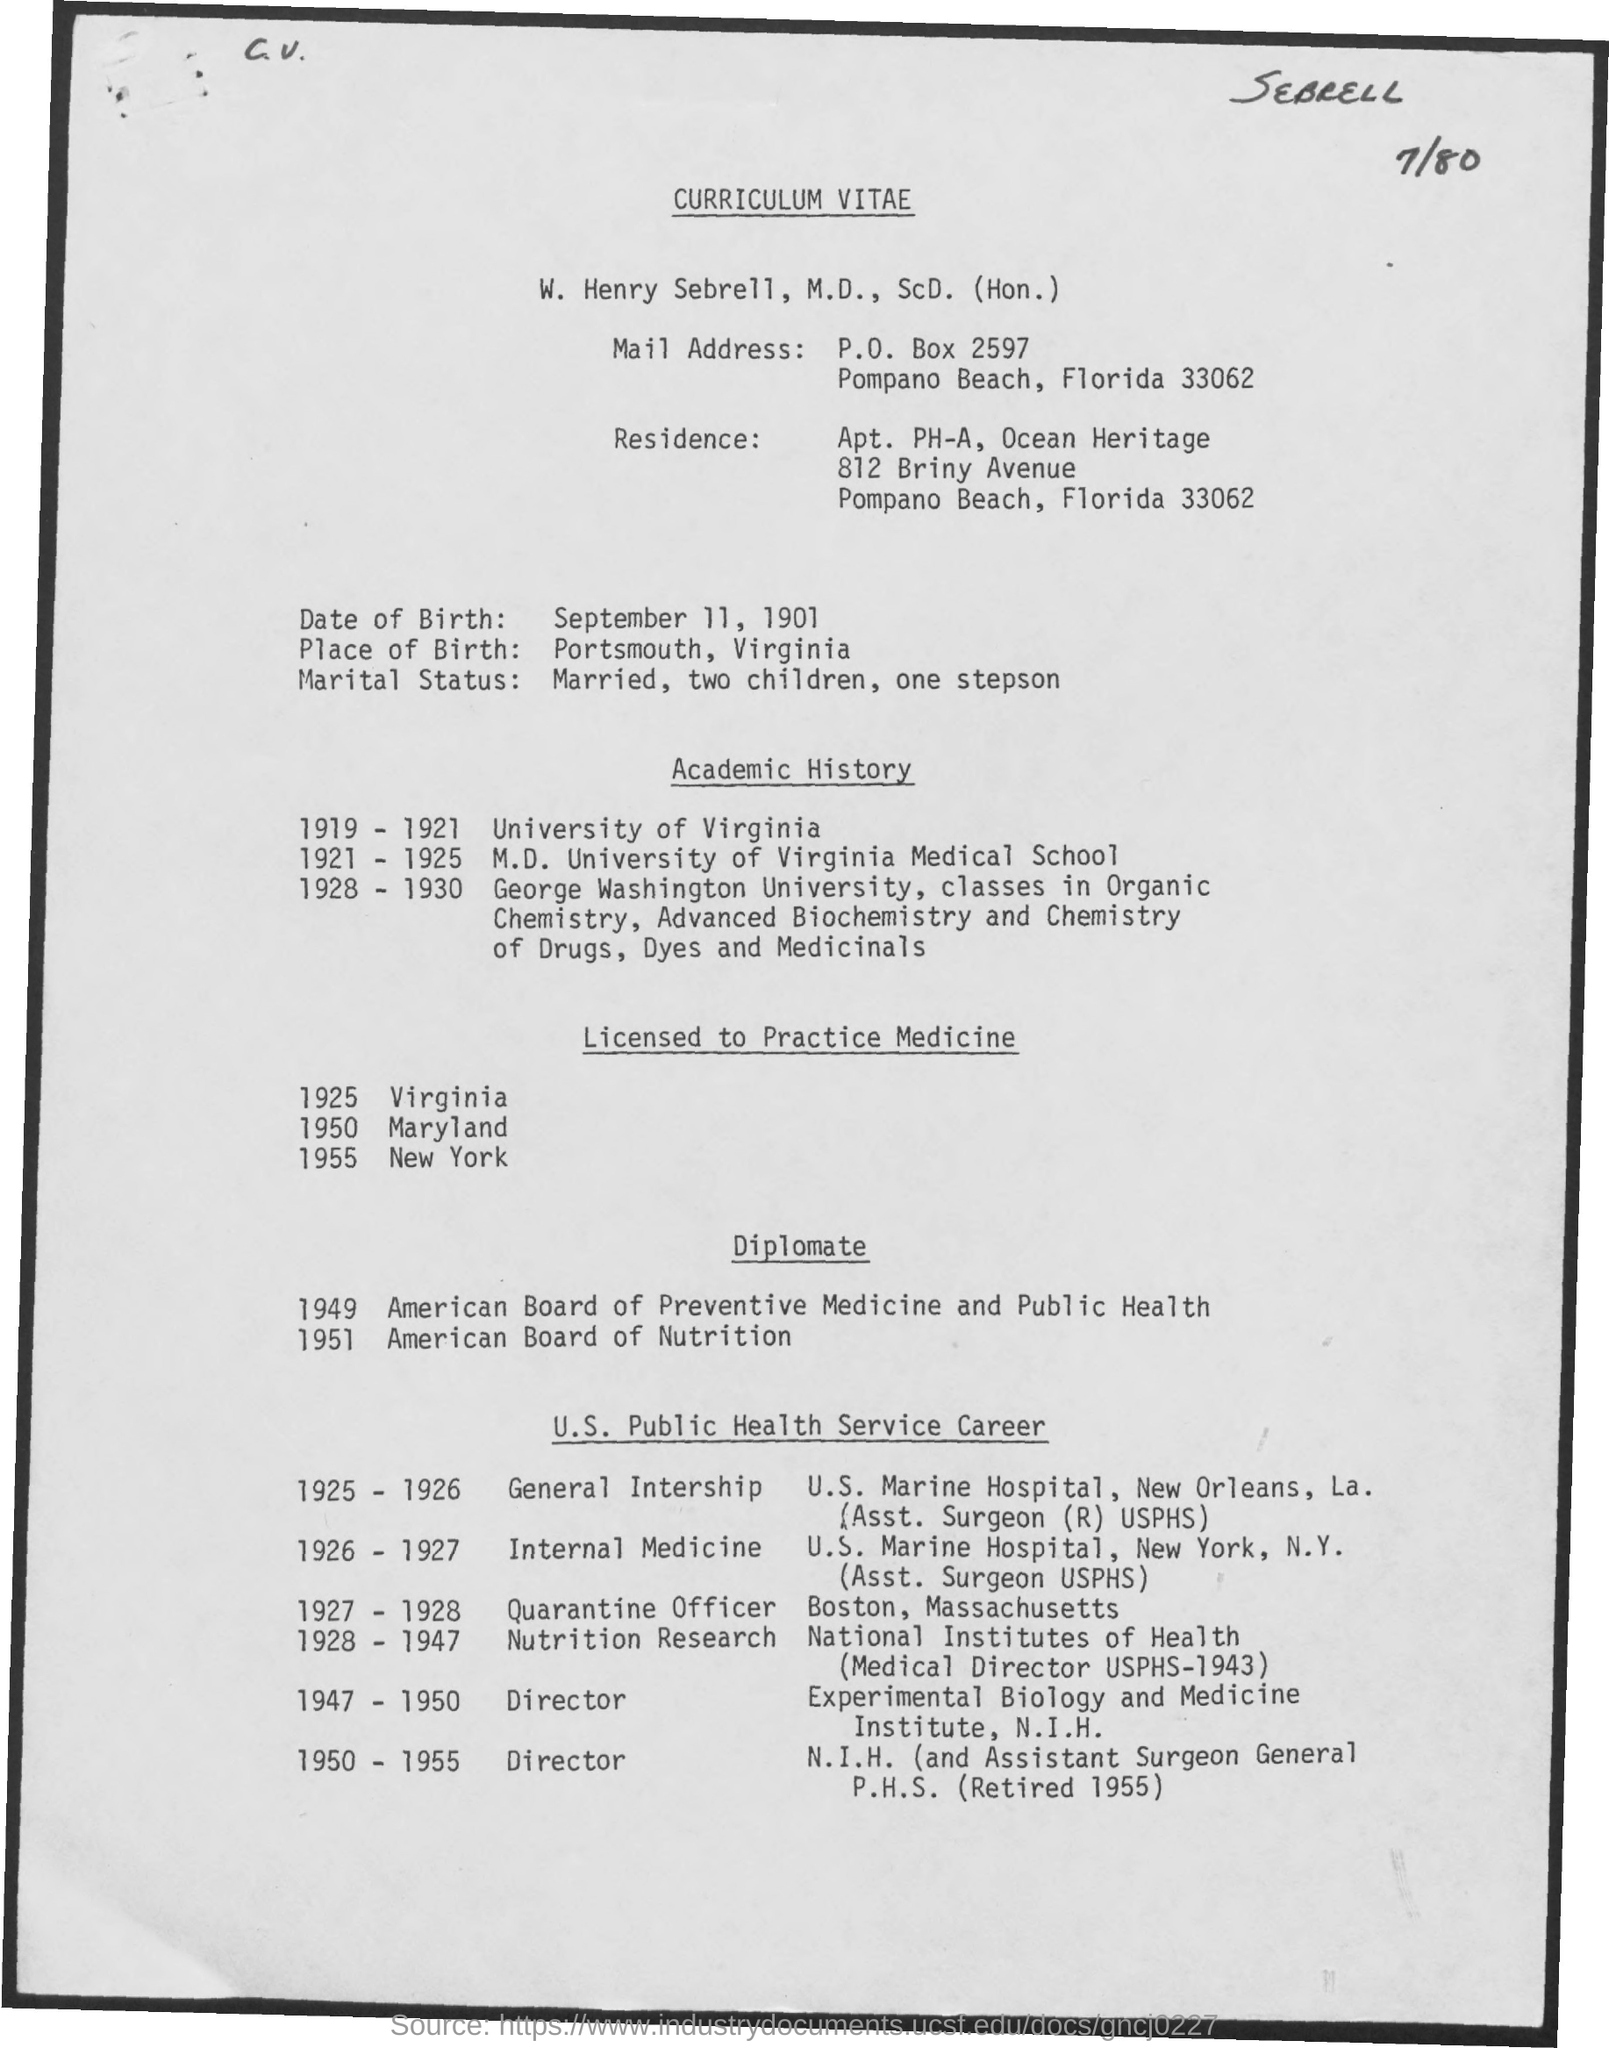Who's Curriculum Vitae is given here?
Your answer should be compact. W. Henry Sebrell. What is the Date of Birth of W. Henry Sebrell, M.D., ScD. (Hon.)?
Your answer should be compact. September 11, 1901. What is the Place of Birth of W. Henry Sebrell, M.D., ScD. (Hon.)?
Offer a very short reply. Portsmouth, Virginia. Which place W. Henry Sebrell, M.D., ScD. (Hon.) was licensed to practice medicine in 1925?
Ensure brevity in your answer.  Virginia. When did W. Henry Sebrell, M.D., ScD. (Hon.) licensed to practice medicine in New York?
Give a very brief answer. 1955. Which place W. Henry Sebrell, M.D., ScD. (Hon.) was licensed to practice medicine in 1950?
Give a very brief answer. Maryland. What is the P.O. Box No mentioned in the Mail Address?
Give a very brief answer. 2597. 